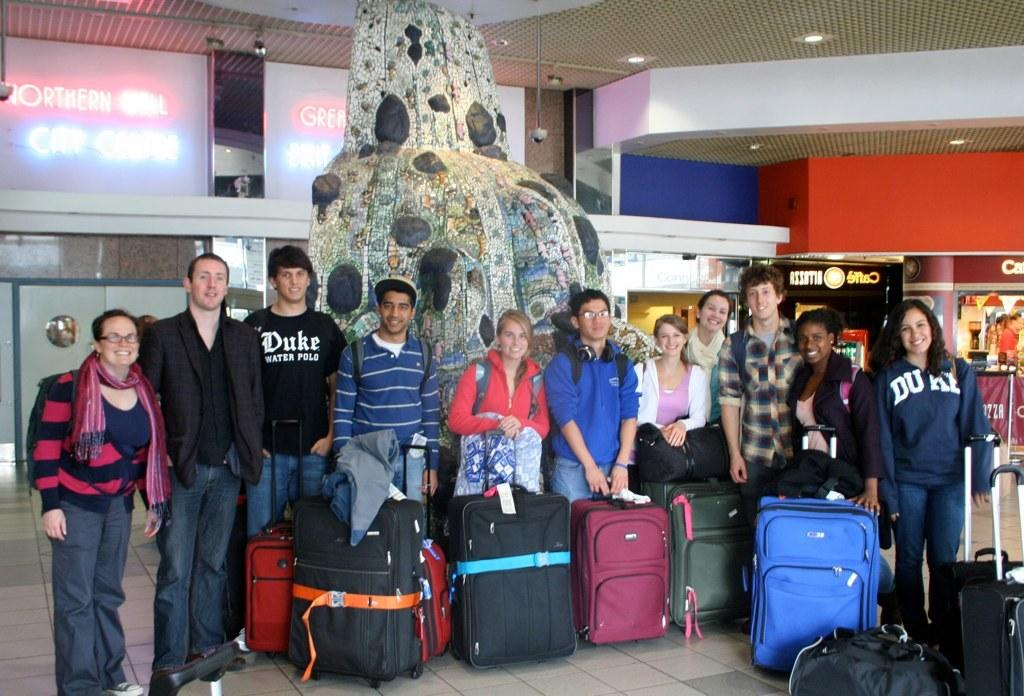Who or what is present in the image? There are people in the image. What are the people doing in the image? The people are standing with their suitcase and luggage. What scientific discovery can be seen in the image? There is no scientific discovery present in the image; it features people standing with their suitcase and luggage. Can you describe the spot where the people are standing in the image? The provided facts do not mention a specific spot or location where the people are standing. 